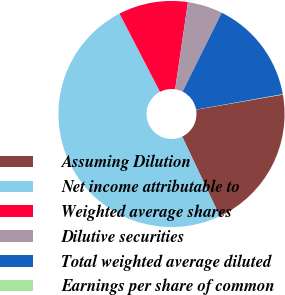Convert chart. <chart><loc_0><loc_0><loc_500><loc_500><pie_chart><fcel>Assuming Dilution<fcel>Net income attributable to<fcel>Weighted average shares<fcel>Dilutive securities<fcel>Total weighted average diluted<fcel>Earnings per share of common<nl><fcel>20.72%<fcel>49.42%<fcel>9.93%<fcel>5.0%<fcel>14.87%<fcel>0.06%<nl></chart> 